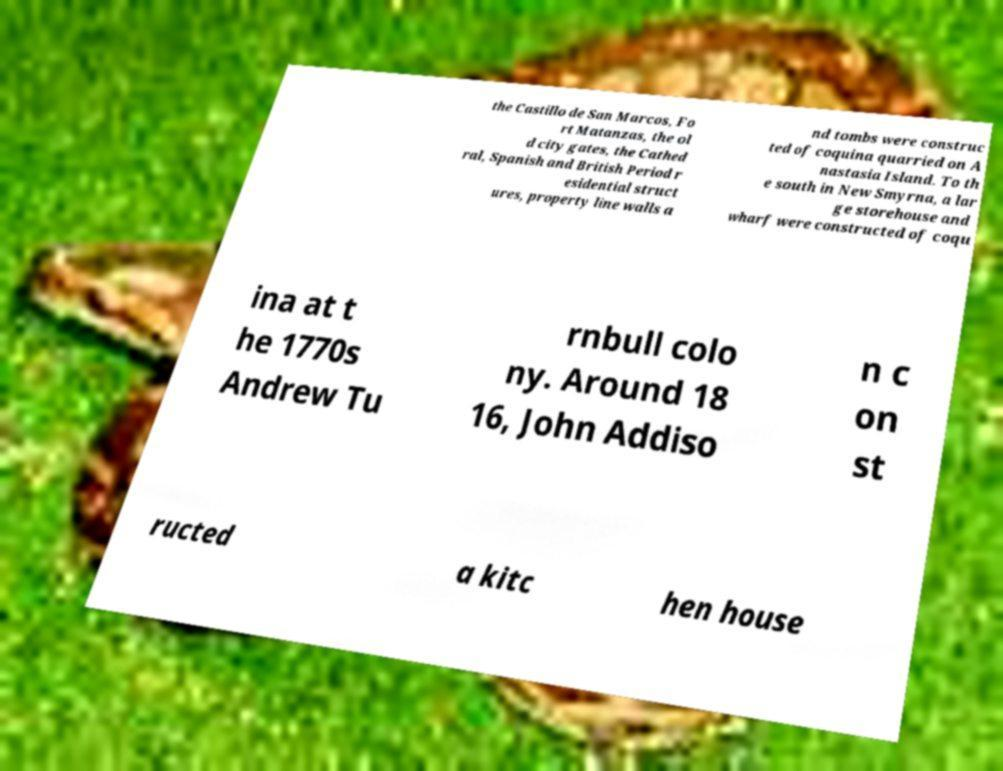I need the written content from this picture converted into text. Can you do that? the Castillo de San Marcos, Fo rt Matanzas, the ol d city gates, the Cathed ral, Spanish and British Period r esidential struct ures, property line walls a nd tombs were construc ted of coquina quarried on A nastasia Island. To th e south in New Smyrna, a lar ge storehouse and wharf were constructed of coqu ina at t he 1770s Andrew Tu rnbull colo ny. Around 18 16, John Addiso n c on st ructed a kitc hen house 